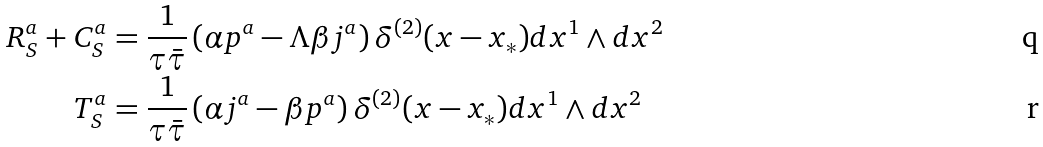<formula> <loc_0><loc_0><loc_500><loc_500>R _ { S } ^ { a } + C _ { S } ^ { a } & = \frac { 1 } { \tau \bar { \tau } } \left ( \alpha p ^ { a } - \Lambda \beta j ^ { a } \right ) \delta ^ { ( 2 ) } ( x - x _ { * } ) d x ^ { 1 } \wedge d x ^ { 2 } \\ T _ { S } ^ { a } & = \frac { 1 } { \tau \bar { \tau } } \left ( \alpha j ^ { a } - \beta p ^ { a } \right ) \delta ^ { ( 2 ) } ( x - x _ { * } ) d x ^ { 1 } \wedge d x ^ { 2 }</formula> 